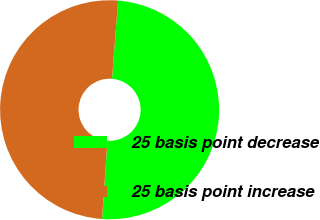<chart> <loc_0><loc_0><loc_500><loc_500><pie_chart><fcel>25 basis point decrease<fcel>25 basis point increase<nl><fcel>49.86%<fcel>50.14%<nl></chart> 